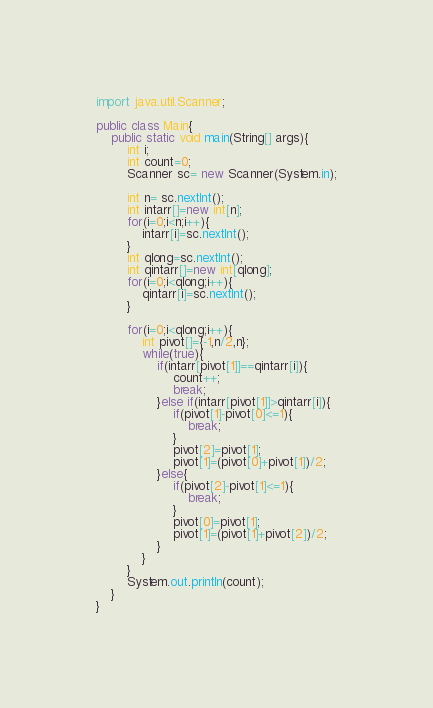<code> <loc_0><loc_0><loc_500><loc_500><_Java_>import java.util.Scanner;

public class Main{
    public static void main(String[] args){
        int i;
        int count=0;
        Scanner sc= new Scanner(System.in);
        
        int n= sc.nextInt();
        int intarr[]=new int[n];
        for(i=0;i<n;i++){
            intarr[i]=sc.nextInt(); 
        }
        int qlong=sc.nextInt();
        int qintarr[]=new int[qlong];
        for(i=0;i<qlong;i++){
            qintarr[i]=sc.nextInt();
        }
       
        for(i=0;i<qlong;i++){
            int pivot[]={-1,n/2,n};
            while(true){
                if(intarr[pivot[1]]==qintarr[i]){
                    count++;
                    break;
                }else if(intarr[pivot[1]]>qintarr[i]){
                    if(pivot[1]-pivot[0]<=1){
                        break;
                    }
                    pivot[2]=pivot[1];
                    pivot[1]=(pivot[0]+pivot[1])/2;
                }else{
                    if(pivot[2]-pivot[1]<=1){
                        break;
                    }
                    pivot[0]=pivot[1];
                    pivot[1]=(pivot[1]+pivot[2])/2;
                }
            }         
        }
        System.out.println(count);
    }
}
</code> 